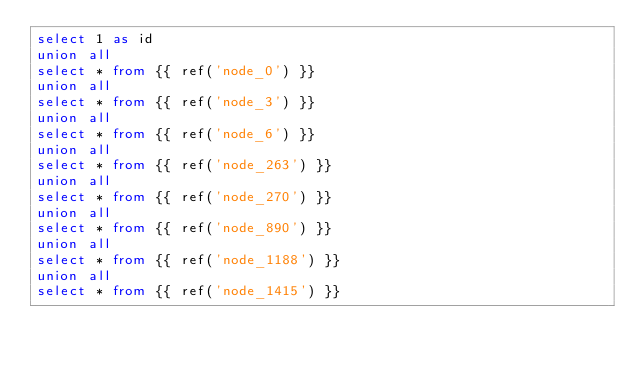Convert code to text. <code><loc_0><loc_0><loc_500><loc_500><_SQL_>select 1 as id
union all
select * from {{ ref('node_0') }}
union all
select * from {{ ref('node_3') }}
union all
select * from {{ ref('node_6') }}
union all
select * from {{ ref('node_263') }}
union all
select * from {{ ref('node_270') }}
union all
select * from {{ ref('node_890') }}
union all
select * from {{ ref('node_1188') }}
union all
select * from {{ ref('node_1415') }}
</code> 